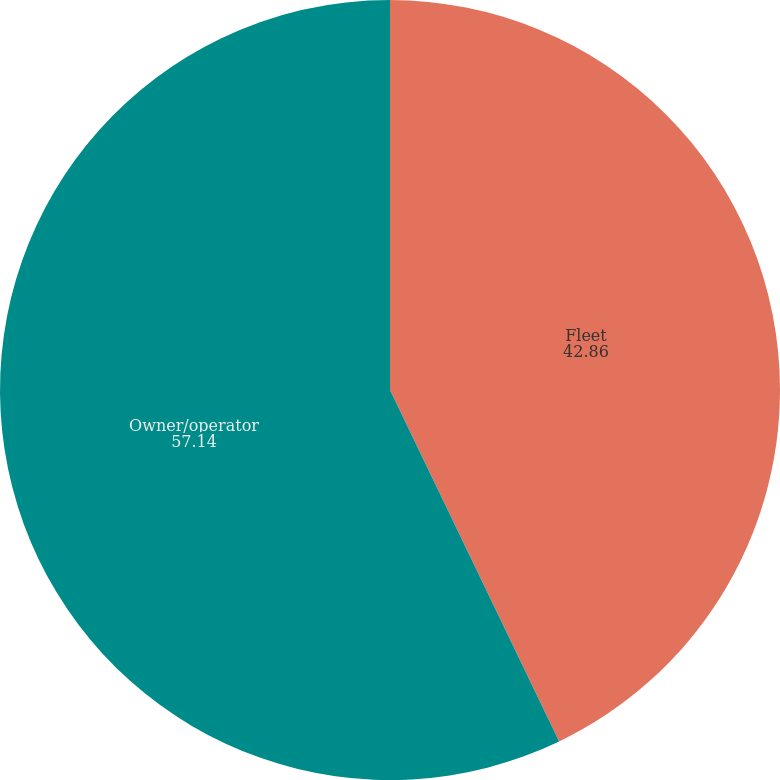<chart> <loc_0><loc_0><loc_500><loc_500><pie_chart><fcel>Fleet<fcel>Owner/operator<nl><fcel>42.86%<fcel>57.14%<nl></chart> 